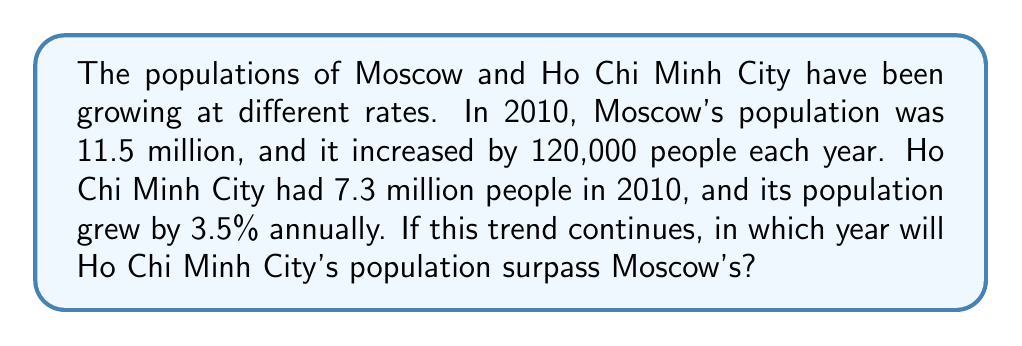Solve this math problem. Let's approach this step-by-step:

1) First, let's create equations for the populations of both cities over time:

   Moscow: $M(t) = 11.5 + 0.12t$
   Ho Chi Minh City: $H(t) = 7.3 \times (1.035)^t$

   Where $t$ is the number of years since 2010.

2) We need to find when $H(t) > M(t)$:

   $7.3 \times (1.035)^t > 11.5 + 0.12t$

3) This equation can't be solved algebraically, so we'll use a year-by-year approach:

   Year 2010 ($t=0$):
   $M(0) = 11.5$, $H(0) = 7.3$

   Year 2015 ($t=5$):
   $M(5) = 11.5 + 0.12 \times 5 = 12.1$
   $H(5) = 7.3 \times (1.035)^5 \approx 8.67$

   Year 2020 ($t=10$):
   $M(10) = 11.5 + 0.12 \times 10 = 12.7$
   $H(10) = 7.3 \times (1.035)^{10} \approx 10.30$

   Year 2025 ($t=15$):
   $M(15) = 11.5 + 0.12 \times 15 = 13.3$
   $H(15) = 7.3 \times (1.035)^{15} \approx 12.23$

   Year 2030 ($t=20$):
   $M(20) = 11.5 + 0.12 \times 20 = 13.9$
   $H(20) = 7.3 \times (1.035)^{20} \approx 14.52$

4) We can see that Ho Chi Minh City's population surpasses Moscow's between 2025 and 2030.

5) To find the exact year, we can check each year between 2025 and 2030:

   Year 2026 ($t=16$):
   $M(16) = 13.42$, $H(16) \approx 12.66$

   Year 2027 ($t=17$):
   $M(17) = 13.54$, $H(17) \approx 13.10$

   Year 2028 ($t=18$):
   $M(18) = 13.66$, $H(18) \approx 13.56$

   Year 2029 ($t=19$):
   $M(19) = 13.78$, $H(19) \approx 14.03$

Therefore, Ho Chi Minh City's population will surpass Moscow's in 2029.
Answer: 2029 